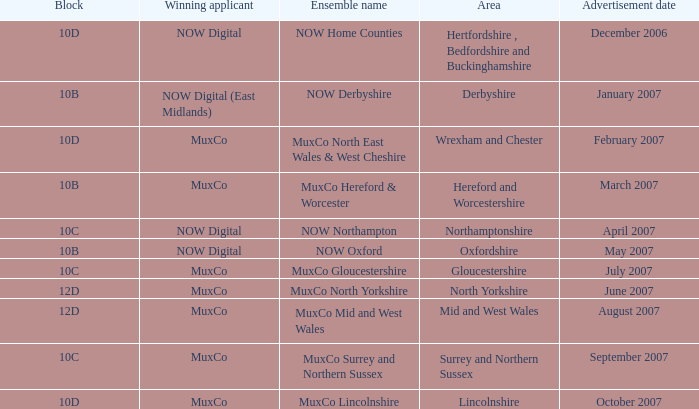Which Ensemble Name has the Advertisement date October 2007? MuxCo Lincolnshire. 